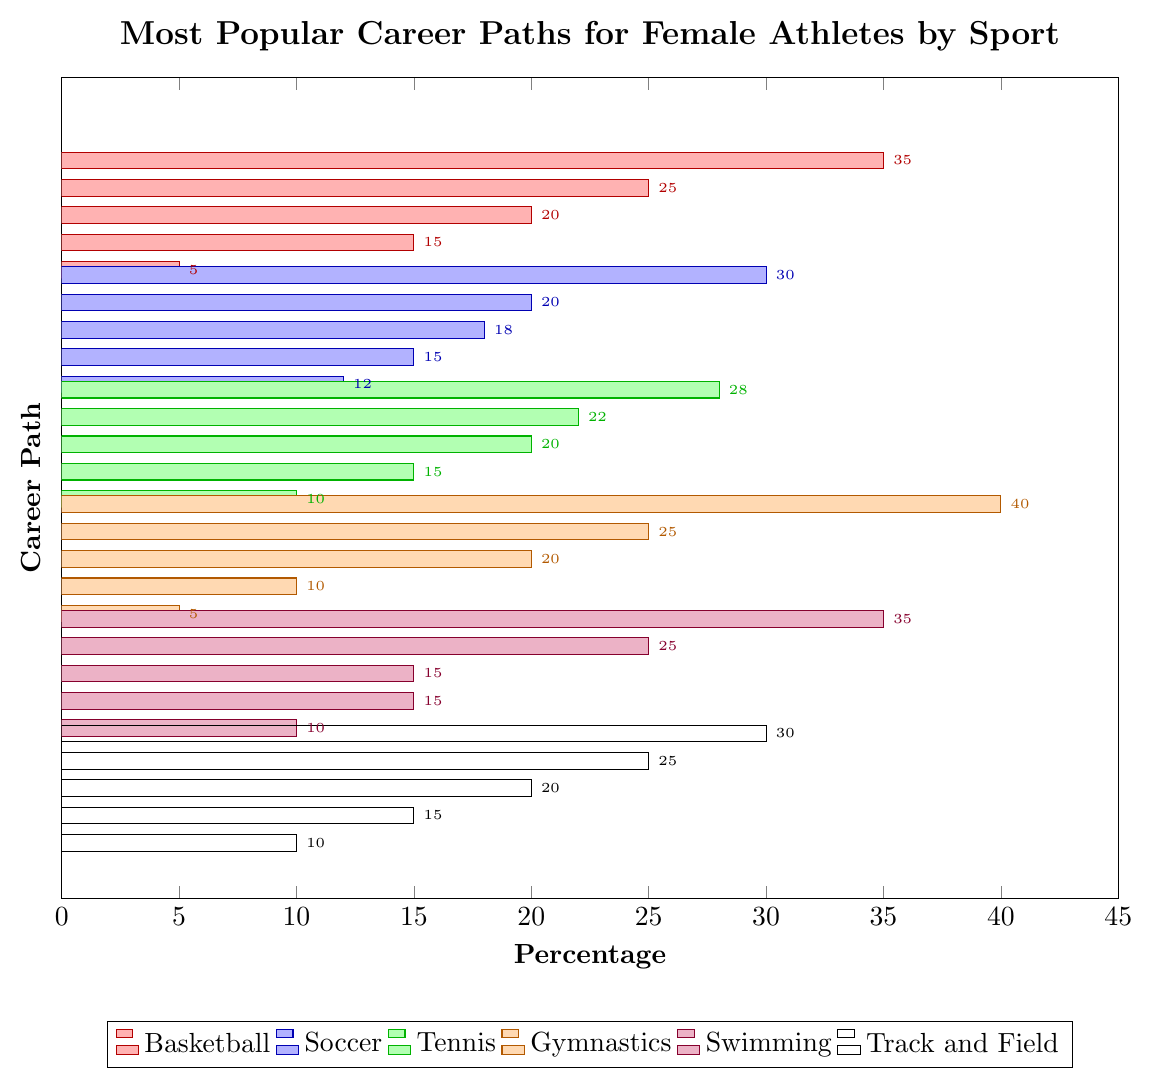What is the most popular career path for female athletes in gymnastics? The tallest bar for gymnastics represents the career path "Coaching" with 40%, indicating it is the most popular career path for female athletes in gymnastics.
Answer: Coaching Which sport has the highest percentage of female athletes going into Fitness Training? Compare the "Fitness Training" bars across all sports. Gymnastics has the highest percentage at 20%.
Answer: Gymnastics What is the total percentage of female basketball athletes pursuing Sports Broadcasting and Physical Therapy combined? Add the percentages for Sports Broadcasting and Physical Therapy in basketball: 25% + 5% = 30%.
Answer: 30% How much higher is the percentage of female athletes pursuing Coaching in gymnastics compared to soccer? Subtract the percentage of Coaching in soccer (30%) from gymnastics (40%): 40% - 30% = 10%.
Answer: 10% Which career path is least popular among female athletes in soccer? The shortest bar for soccer represents "Sports Psychology" with 12%, making it the least popular.
Answer: Sports Psychology In which sport is the percentage of female athletes pursuing Business/Entrepreneurship the highest? Compare the "Business/Entrepreneurship" bars across all sports. Basketball has the highest percentage at 20%.
Answer: Basketball What is the average percentage of female athletes in basketball pursuing non-Coaching career paths? Sum the percentages for non-Coaching career paths in basketball (25% + 20% + 15% + 5% = 65%) and divide by the number of these paths (4): 65% / 4 ≈ 16.25%.
Answer: 16.25% Are there any career paths pursued equally by female athletes in two different sports? If so, which ones? Compare the percentages for each career path across different sports. Physical Therapy in basketball and gymnastics both have 25%, and Athletic Administration in basketball and track and field both have 15%.
Answer: Physical Therapy (basketball and gymnastics), Athletic Administration (basketball and track and field) Which sport has the most evenly distributed career path percentages, and how can you tell? Swimming has relatively close percentages: Coaching (35%), Physical Education Teaching (25%), Sports Science Research (15%), Aquatics Management (15%), Sports Nutrition (10%), indicating a more even distribution.
Answer: Swimming Between Tennis and Track and Field, which sport has the higher percentage of athletes in Athletic Administration? The percentage for Athletic Administration in basketball is 15%, and in track and field, it is also 15%. Both sports are equal.
Answer: Equal, both at 15% 